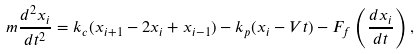Convert formula to latex. <formula><loc_0><loc_0><loc_500><loc_500>m \frac { d ^ { 2 } x _ { i } } { d t ^ { 2 } } = k _ { c } ( x _ { i + 1 } - 2 x _ { i } + x _ { i - 1 } ) - k _ { p } ( x _ { i } - V t ) - F _ { f } \left ( \frac { d x _ { i } } { d t } \right ) ,</formula> 